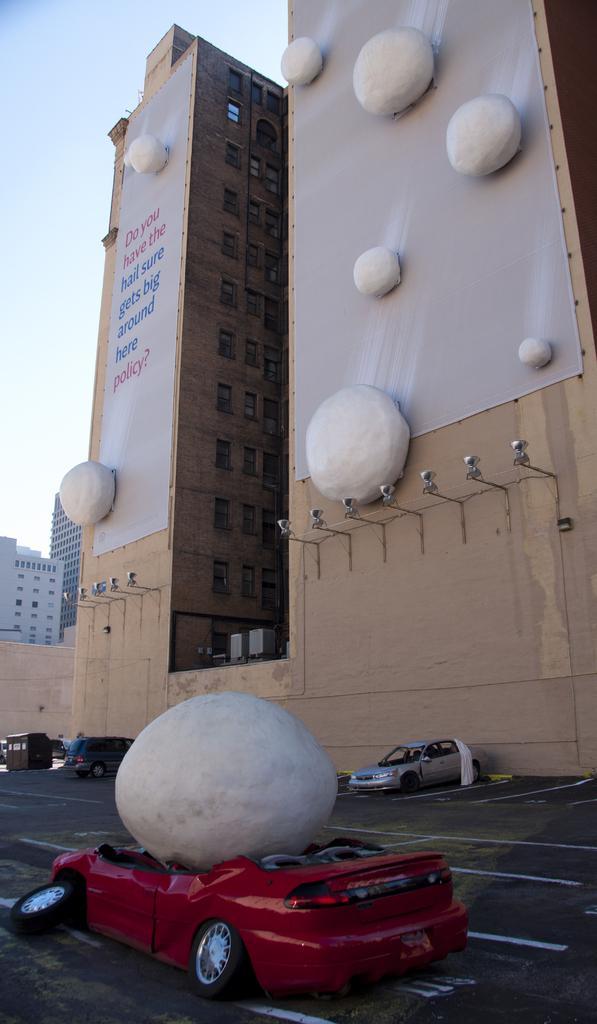Please provide a concise description of this image. This is a building with the windows. I can see a banner, which is attached to the wall. I think these are the rocks, which are white in color. I think these are the lamps. These are the vehicles, which are parked. This is the rock, which is above the car. 